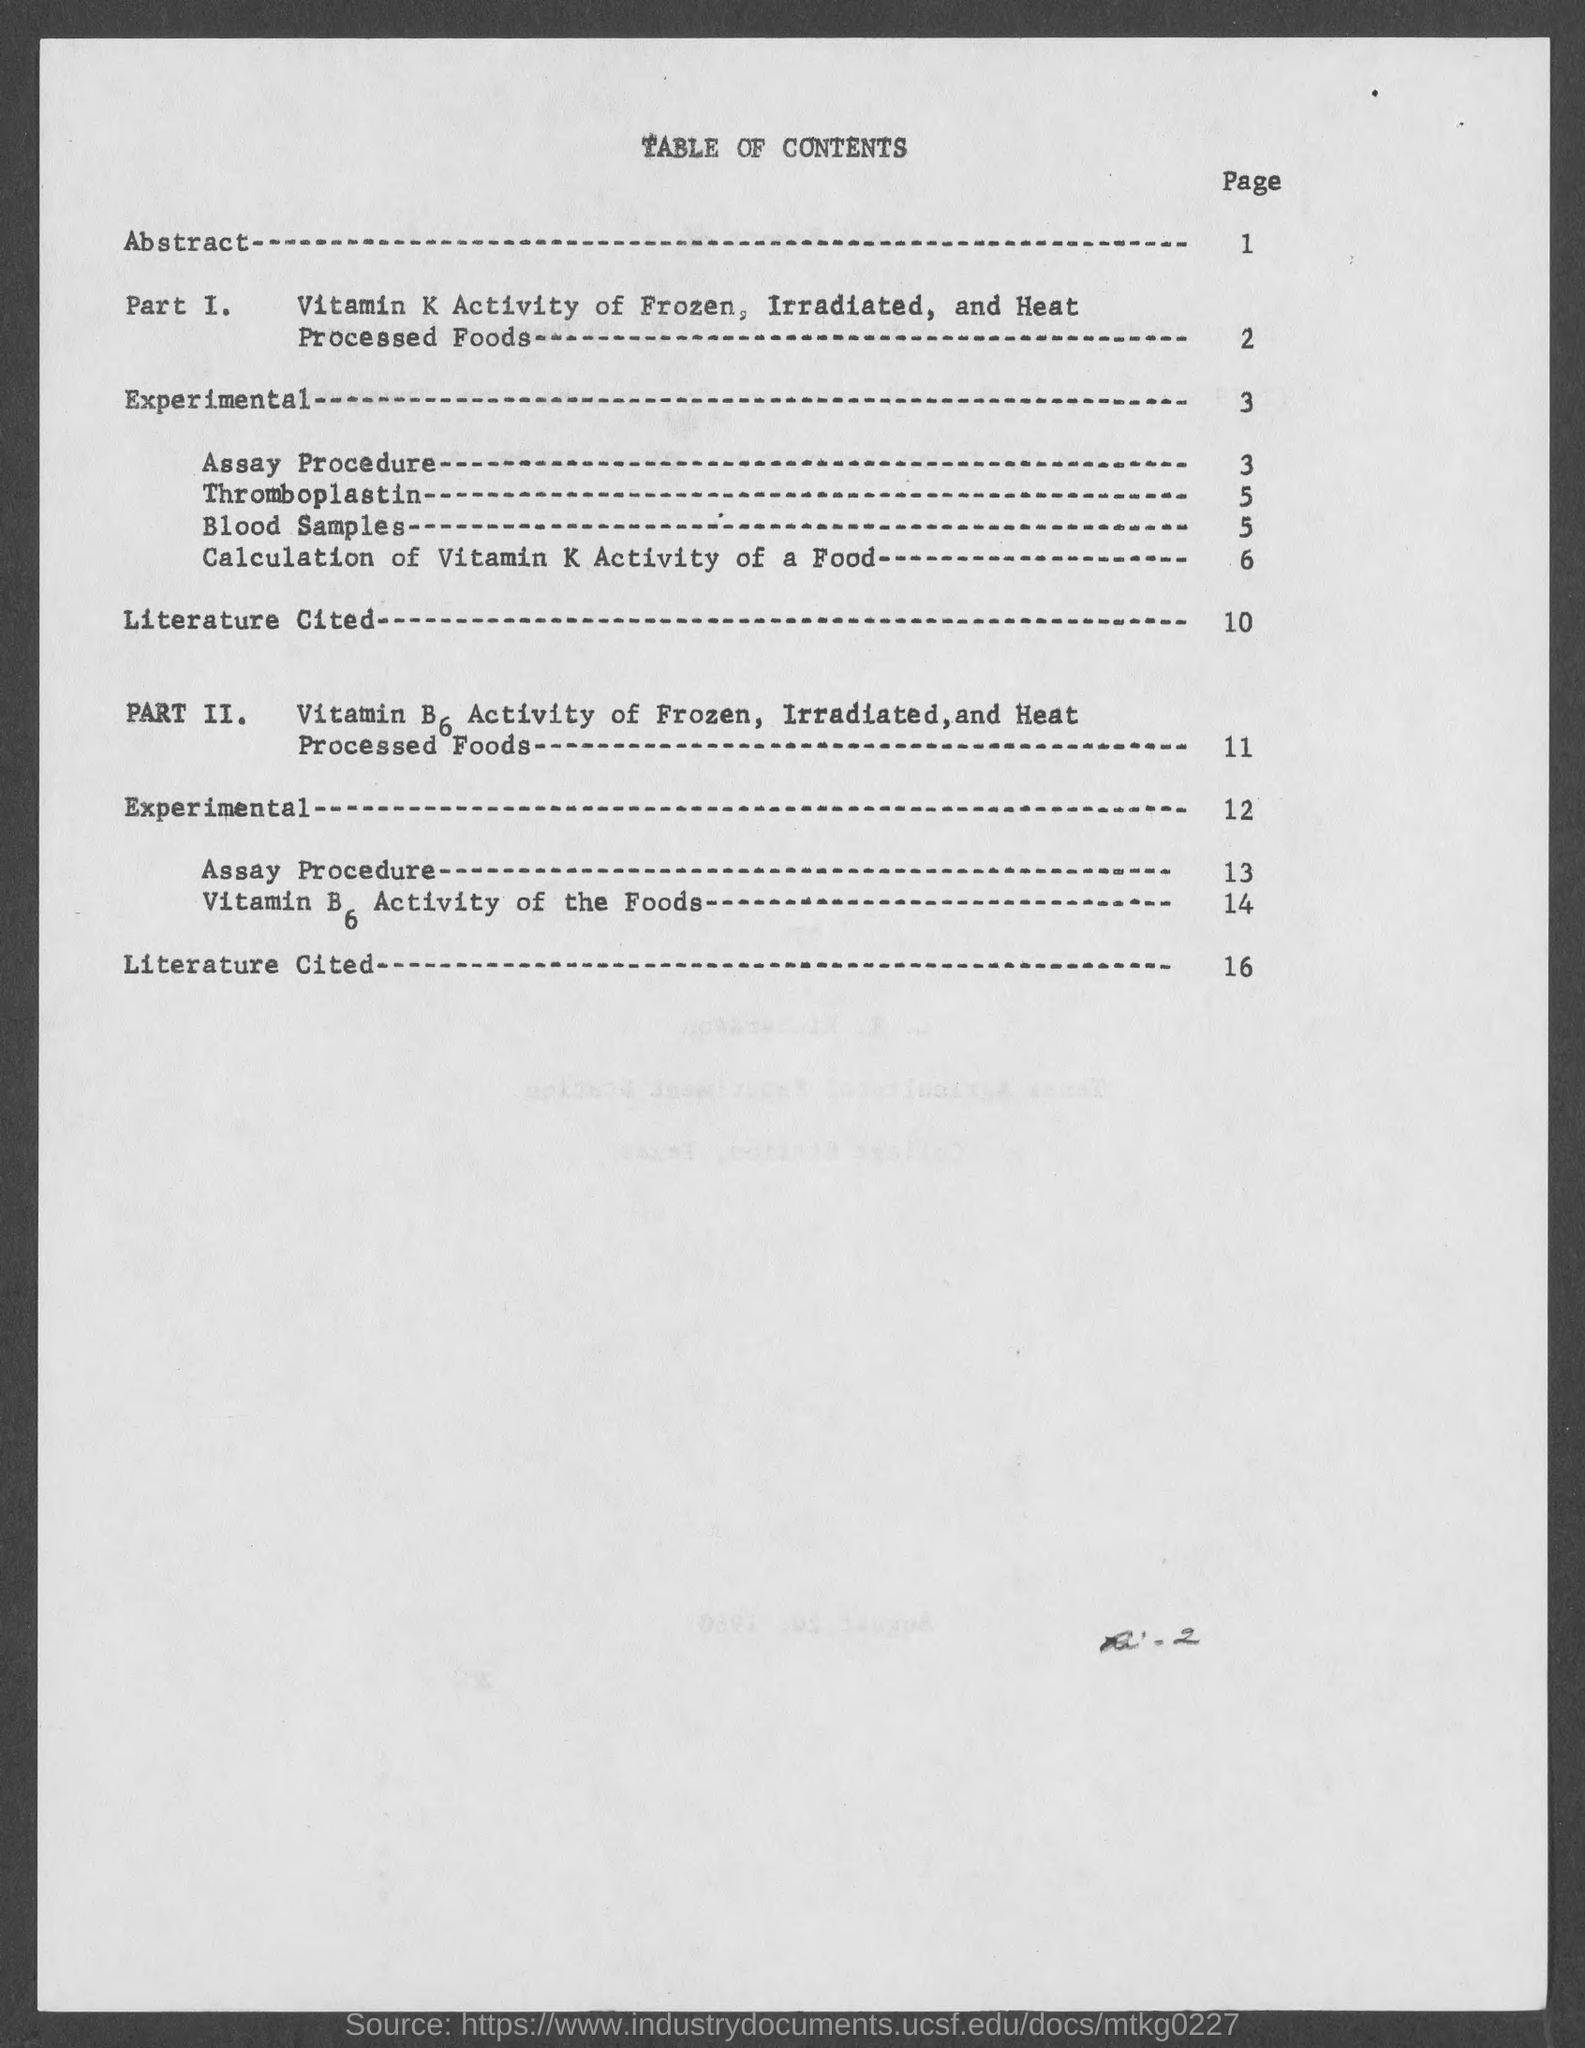What is the page number of abstract ?
Ensure brevity in your answer.  1. What is the page number for thromboplastin?
Keep it short and to the point. 5. What is the page number for blood samples ?
Give a very brief answer. 5. What is the page number for calculation of vitamin k activity of a food ?
Offer a terse response. 6. What is the title of the page ?
Keep it short and to the point. Table of contents. 